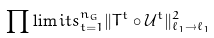Convert formula to latex. <formula><loc_0><loc_0><loc_500><loc_500>\prod \lim i t s _ { t = 1 } ^ { n _ { G } } \| T ^ { t } \circ \mathcal { U } ^ { t } \| _ { \ell _ { 1 } \to \ell _ { 1 } } ^ { 2 }</formula> 